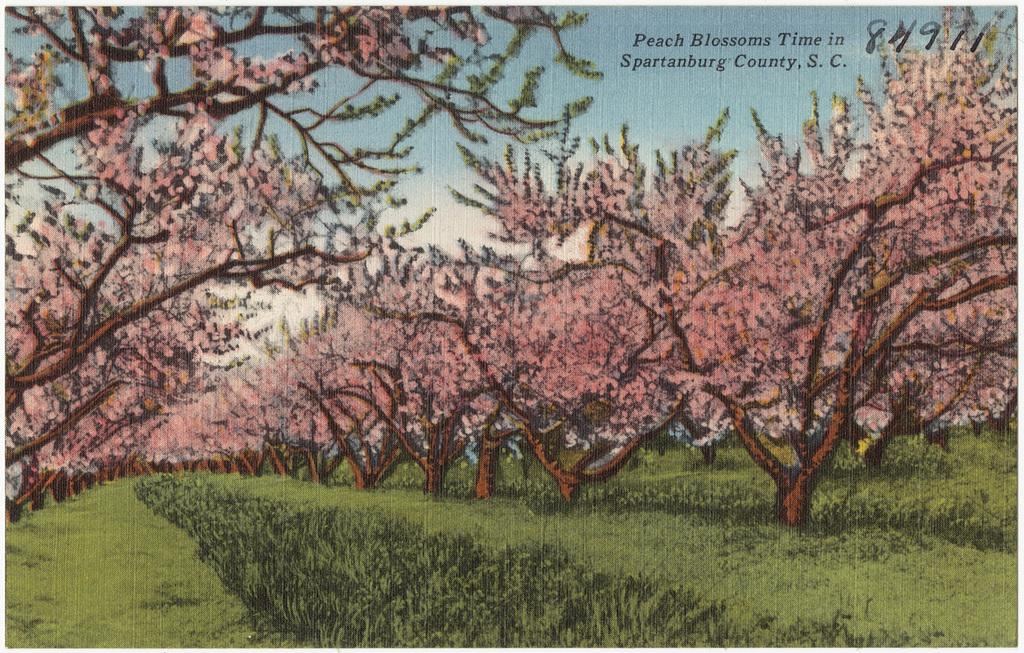What style is the image drawn in? The image is a cartoon. What type of natural environment is depicted in the image? There are trees and grass in the image. Is there any text present in the image? Yes, there is text in the image. What can be seen at the top of the image? The sky is visible at the top of the image. How does the heart react to the kiss in the image? There is no heart or kiss present in the image. 